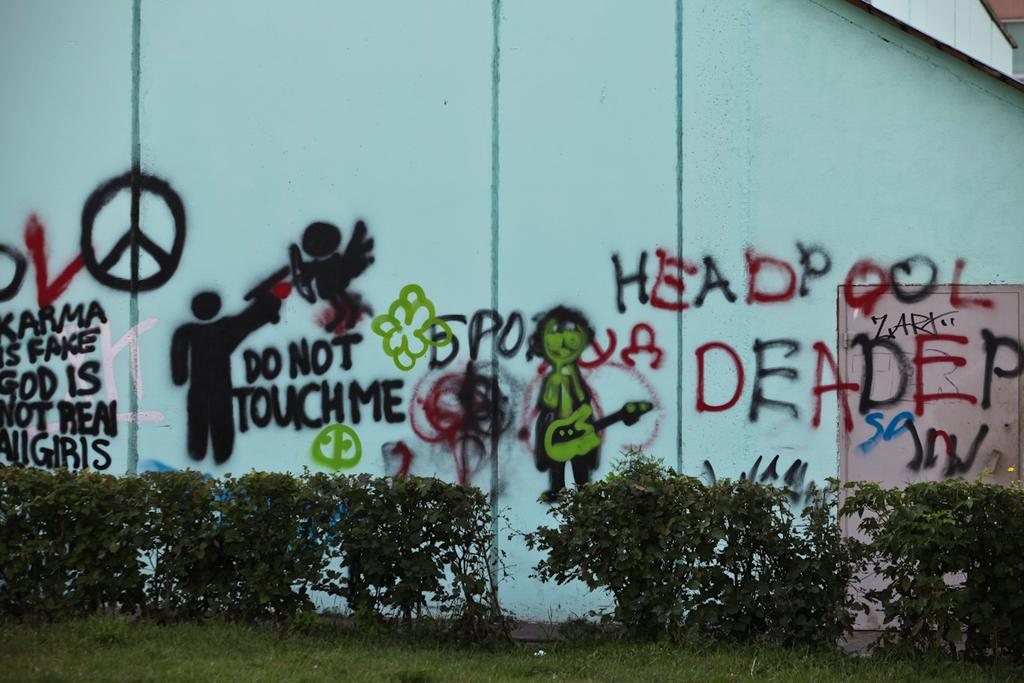What is displayed on the wall in the image? There are arts on the wall in the image. What type of vegetation is present beside the wall? There are shrubs beside the wall in the image. What type of ground cover is visible in the image? There is grass visible in the image. What type of calculator is being used by the celery in the image? There is no calculator or celery present in the image. 